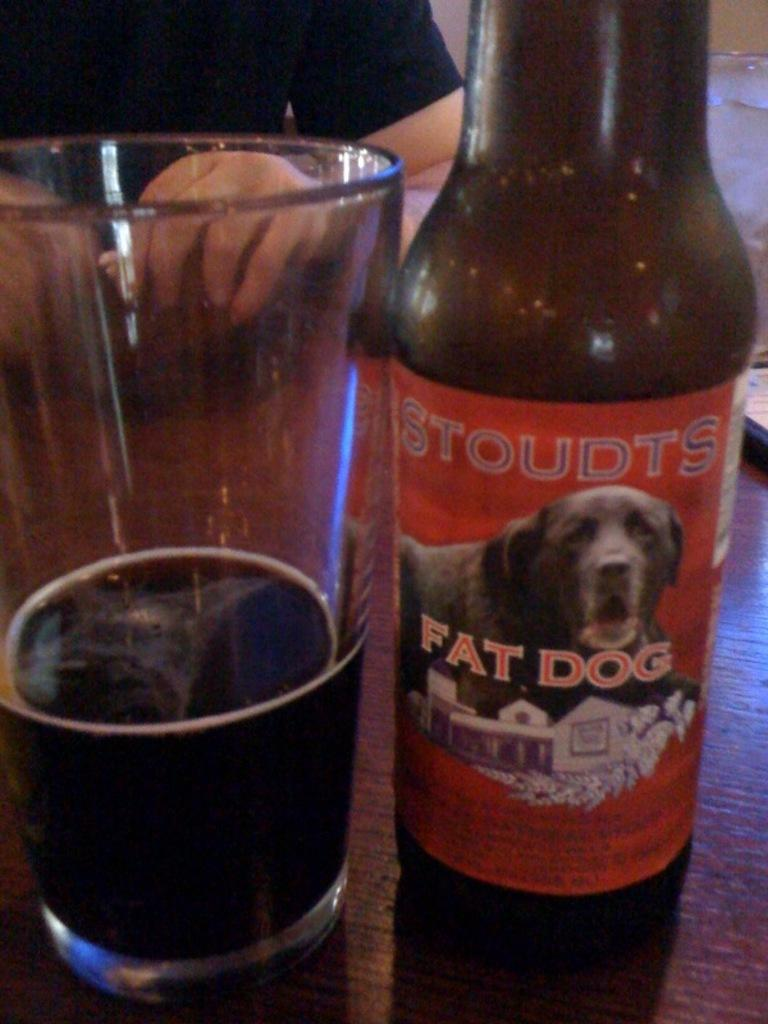<image>
Share a concise interpretation of the image provided. A bottle of Stoudts Fat Dog is sitting beside a glass on a table. 